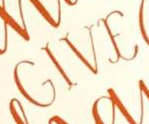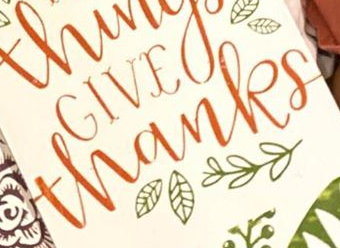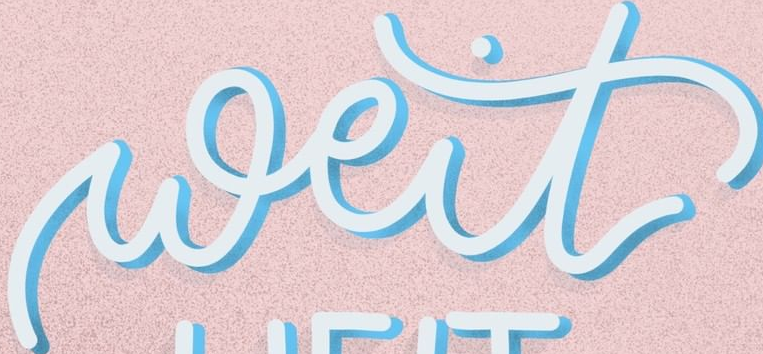What words are shown in these images in order, separated by a semicolon? GIVE; thanks; weit 